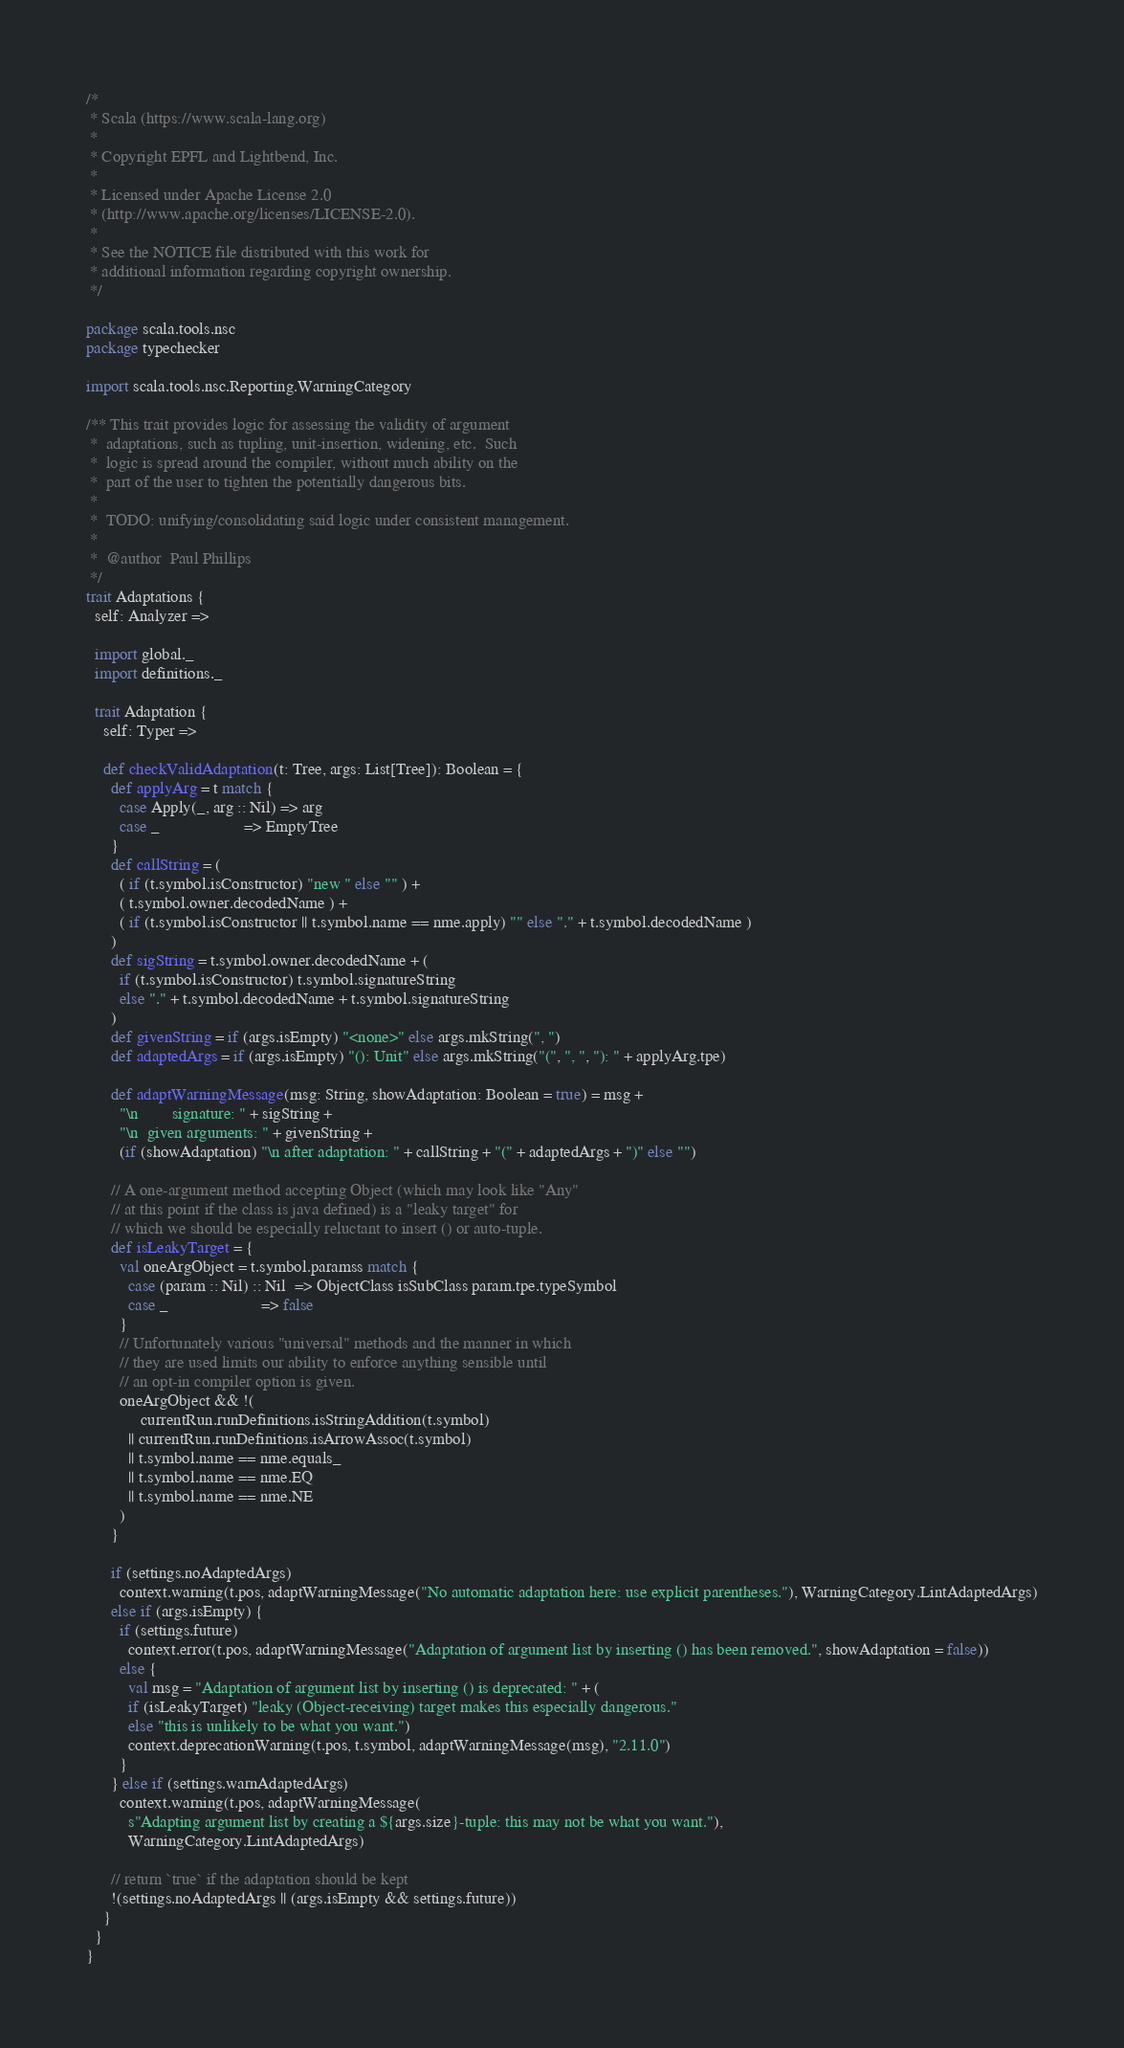Convert code to text. <code><loc_0><loc_0><loc_500><loc_500><_Scala_>/*
 * Scala (https://www.scala-lang.org)
 *
 * Copyright EPFL and Lightbend, Inc.
 *
 * Licensed under Apache License 2.0
 * (http://www.apache.org/licenses/LICENSE-2.0).
 *
 * See the NOTICE file distributed with this work for
 * additional information regarding copyright ownership.
 */

package scala.tools.nsc
package typechecker

import scala.tools.nsc.Reporting.WarningCategory

/** This trait provides logic for assessing the validity of argument
 *  adaptations, such as tupling, unit-insertion, widening, etc.  Such
 *  logic is spread around the compiler, without much ability on the
 *  part of the user to tighten the potentially dangerous bits.
 *
 *  TODO: unifying/consolidating said logic under consistent management.
 *
 *  @author  Paul Phillips
 */
trait Adaptations {
  self: Analyzer =>

  import global._
  import definitions._

  trait Adaptation {
    self: Typer =>

    def checkValidAdaptation(t: Tree, args: List[Tree]): Boolean = {
      def applyArg = t match {
        case Apply(_, arg :: Nil) => arg
        case _                    => EmptyTree
      }
      def callString = (
        ( if (t.symbol.isConstructor) "new " else "" ) +
        ( t.symbol.owner.decodedName ) +
        ( if (t.symbol.isConstructor || t.symbol.name == nme.apply) "" else "." + t.symbol.decodedName )
      )
      def sigString = t.symbol.owner.decodedName + (
        if (t.symbol.isConstructor) t.symbol.signatureString
        else "." + t.symbol.decodedName + t.symbol.signatureString
      )
      def givenString = if (args.isEmpty) "<none>" else args.mkString(", ")
      def adaptedArgs = if (args.isEmpty) "(): Unit" else args.mkString("(", ", ", "): " + applyArg.tpe)

      def adaptWarningMessage(msg: String, showAdaptation: Boolean = true) = msg +
        "\n        signature: " + sigString +
        "\n  given arguments: " + givenString +
        (if (showAdaptation) "\n after adaptation: " + callString + "(" + adaptedArgs + ")" else "")

      // A one-argument method accepting Object (which may look like "Any"
      // at this point if the class is java defined) is a "leaky target" for
      // which we should be especially reluctant to insert () or auto-tuple.
      def isLeakyTarget = {
        val oneArgObject = t.symbol.paramss match {
          case (param :: Nil) :: Nil  => ObjectClass isSubClass param.tpe.typeSymbol
          case _                      => false
        }
        // Unfortunately various "universal" methods and the manner in which
        // they are used limits our ability to enforce anything sensible until
        // an opt-in compiler option is given.
        oneArgObject && !(
             currentRun.runDefinitions.isStringAddition(t.symbol)
          || currentRun.runDefinitions.isArrowAssoc(t.symbol)
          || t.symbol.name == nme.equals_
          || t.symbol.name == nme.EQ
          || t.symbol.name == nme.NE
        )
      }

      if (settings.noAdaptedArgs)
        context.warning(t.pos, adaptWarningMessage("No automatic adaptation here: use explicit parentheses."), WarningCategory.LintAdaptedArgs)
      else if (args.isEmpty) {
        if (settings.future)
          context.error(t.pos, adaptWarningMessage("Adaptation of argument list by inserting () has been removed.", showAdaptation = false))
        else {
          val msg = "Adaptation of argument list by inserting () is deprecated: " + (
          if (isLeakyTarget) "leaky (Object-receiving) target makes this especially dangerous."
          else "this is unlikely to be what you want.")
          context.deprecationWarning(t.pos, t.symbol, adaptWarningMessage(msg), "2.11.0")
        }
      } else if (settings.warnAdaptedArgs)
        context.warning(t.pos, adaptWarningMessage(
          s"Adapting argument list by creating a ${args.size}-tuple: this may not be what you want."),
          WarningCategory.LintAdaptedArgs)

      // return `true` if the adaptation should be kept
      !(settings.noAdaptedArgs || (args.isEmpty && settings.future))
    }
  }
}
</code> 